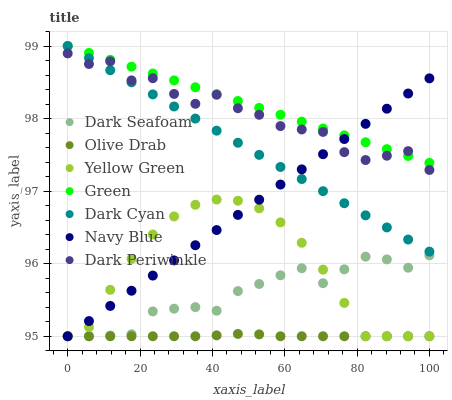Does Olive Drab have the minimum area under the curve?
Answer yes or no. Yes. Does Green have the maximum area under the curve?
Answer yes or no. Yes. Does Navy Blue have the minimum area under the curve?
Answer yes or no. No. Does Navy Blue have the maximum area under the curve?
Answer yes or no. No. Is Green the smoothest?
Answer yes or no. Yes. Is Dark Periwinkle the roughest?
Answer yes or no. Yes. Is Navy Blue the smoothest?
Answer yes or no. No. Is Navy Blue the roughest?
Answer yes or no. No. Does Yellow Green have the lowest value?
Answer yes or no. Yes. Does Green have the lowest value?
Answer yes or no. No. Does Dark Cyan have the highest value?
Answer yes or no. Yes. Does Navy Blue have the highest value?
Answer yes or no. No. Is Yellow Green less than Dark Periwinkle?
Answer yes or no. Yes. Is Dark Periwinkle greater than Olive Drab?
Answer yes or no. Yes. Does Navy Blue intersect Yellow Green?
Answer yes or no. Yes. Is Navy Blue less than Yellow Green?
Answer yes or no. No. Is Navy Blue greater than Yellow Green?
Answer yes or no. No. Does Yellow Green intersect Dark Periwinkle?
Answer yes or no. No. 